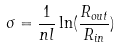Convert formula to latex. <formula><loc_0><loc_0><loc_500><loc_500>\sigma = \frac { 1 } { n l } \ln ( \frac { R _ { o u t } } { R _ { i n } } )</formula> 